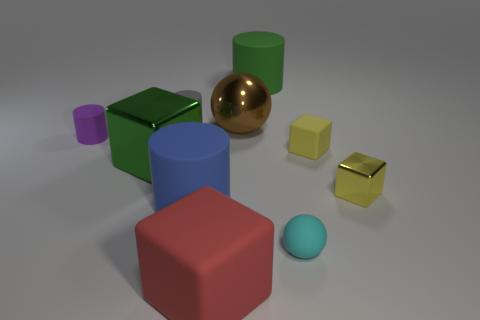The matte cube that is the same color as the tiny metal block is what size?
Offer a very short reply. Small. Does the red matte thing have the same size as the metallic cube that is to the left of the big rubber block?
Your response must be concise. Yes. What number of spheres are large green rubber objects or large yellow metal things?
Your answer should be compact. 0. There is a blue cylinder that is made of the same material as the small gray thing; what is its size?
Your answer should be very brief. Large. There is a sphere that is in front of the purple thing; is it the same size as the purple cylinder that is behind the big blue rubber cylinder?
Ensure brevity in your answer.  Yes. What number of things are either gray objects or cyan matte cubes?
Keep it short and to the point. 1. The large green rubber object is what shape?
Give a very brief answer. Cylinder. What is the size of the other matte thing that is the same shape as the red rubber thing?
Provide a short and direct response. Small. What size is the matte cube to the right of the large shiny object right of the big red block?
Your response must be concise. Small. Are there an equal number of purple matte cylinders that are behind the big blue matte cylinder and tiny cyan matte spheres?
Give a very brief answer. Yes. 